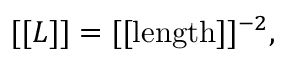<formula> <loc_0><loc_0><loc_500><loc_500>[ [ L ] ] = [ [ l e n g t h ] ] ^ { - 2 } ,</formula> 